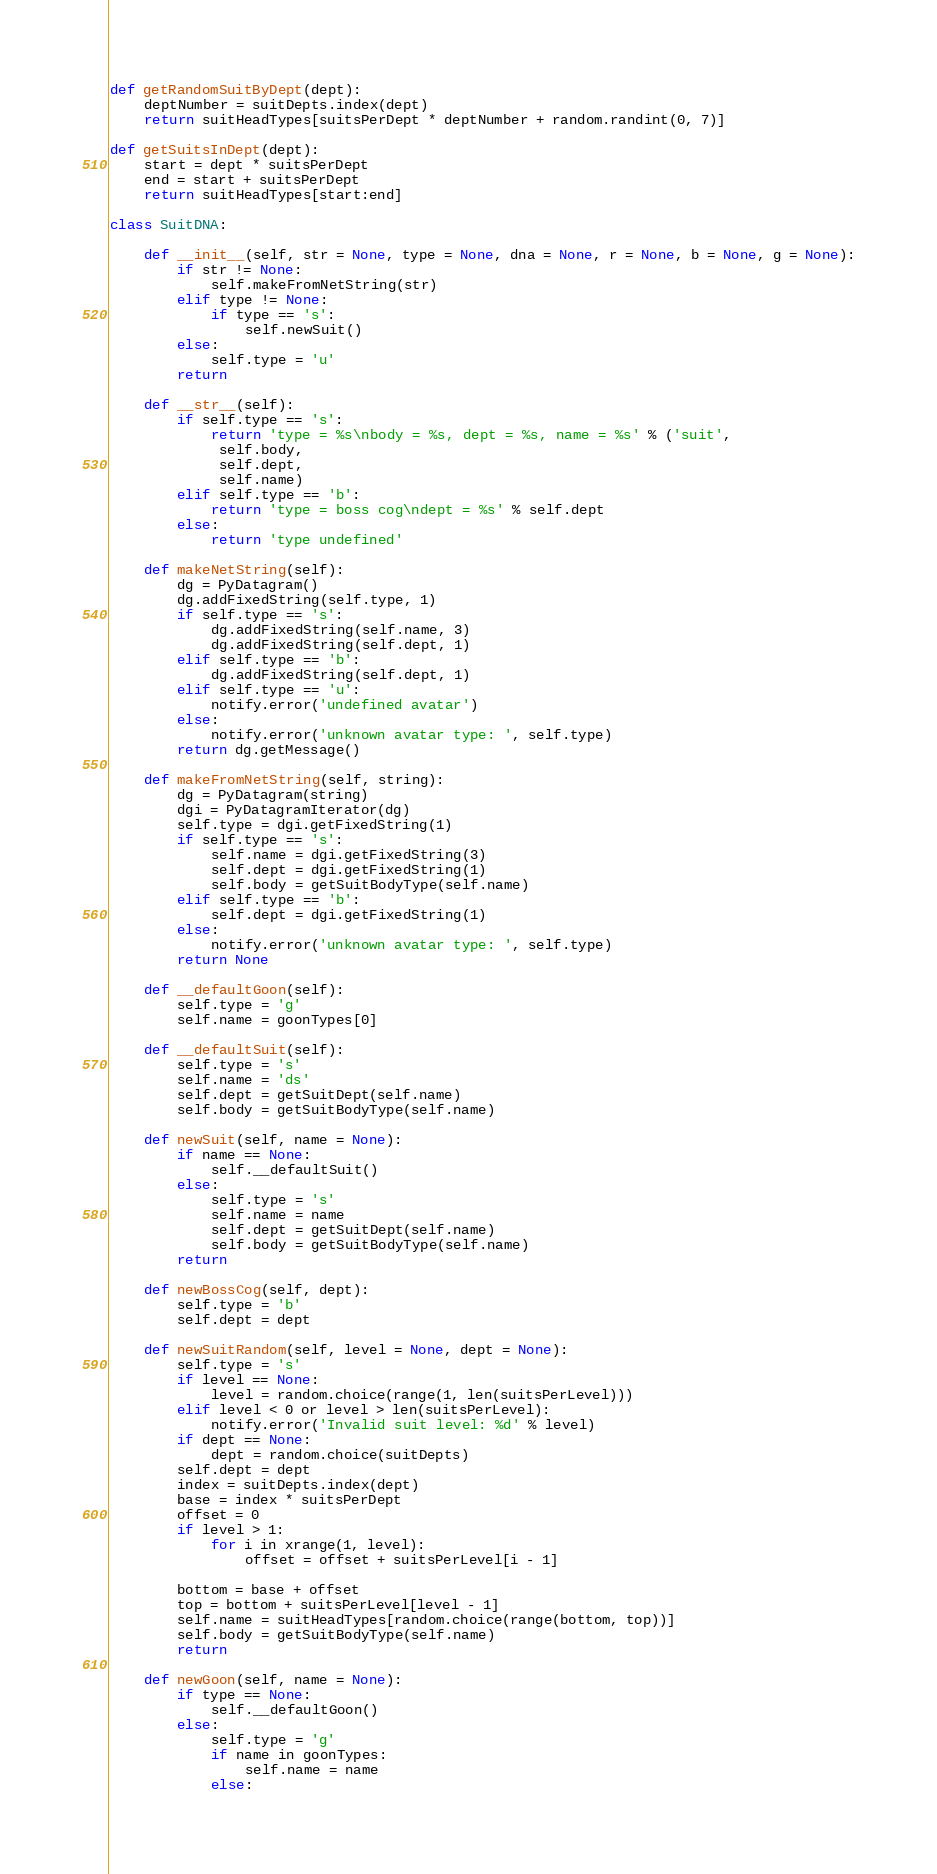Convert code to text. <code><loc_0><loc_0><loc_500><loc_500><_Python_>

def getRandomSuitByDept(dept):
    deptNumber = suitDepts.index(dept)
    return suitHeadTypes[suitsPerDept * deptNumber + random.randint(0, 7)]

def getSuitsInDept(dept):
    start = dept * suitsPerDept
    end = start + suitsPerDept
    return suitHeadTypes[start:end]

class SuitDNA:

    def __init__(self, str = None, type = None, dna = None, r = None, b = None, g = None):
        if str != None:
            self.makeFromNetString(str)
        elif type != None:
            if type == 's':
                self.newSuit()
        else:
            self.type = 'u'
        return

    def __str__(self):
        if self.type == 's':
            return 'type = %s\nbody = %s, dept = %s, name = %s' % ('suit',
             self.body,
             self.dept,
             self.name)
        elif self.type == 'b':
            return 'type = boss cog\ndept = %s' % self.dept
        else:
            return 'type undefined'

    def makeNetString(self):
        dg = PyDatagram()
        dg.addFixedString(self.type, 1)
        if self.type == 's':
            dg.addFixedString(self.name, 3)
            dg.addFixedString(self.dept, 1)
        elif self.type == 'b':
            dg.addFixedString(self.dept, 1)
        elif self.type == 'u':
            notify.error('undefined avatar')
        else:
            notify.error('unknown avatar type: ', self.type)
        return dg.getMessage()

    def makeFromNetString(self, string):
        dg = PyDatagram(string)
        dgi = PyDatagramIterator(dg)
        self.type = dgi.getFixedString(1)
        if self.type == 's':
            self.name = dgi.getFixedString(3)
            self.dept = dgi.getFixedString(1)
            self.body = getSuitBodyType(self.name)
        elif self.type == 'b':
            self.dept = dgi.getFixedString(1)
        else:
            notify.error('unknown avatar type: ', self.type)
        return None

    def __defaultGoon(self):
        self.type = 'g'
        self.name = goonTypes[0]

    def __defaultSuit(self):
        self.type = 's'
        self.name = 'ds'
        self.dept = getSuitDept(self.name)
        self.body = getSuitBodyType(self.name)

    def newSuit(self, name = None):
        if name == None:
            self.__defaultSuit()
        else:
            self.type = 's'
            self.name = name
            self.dept = getSuitDept(self.name)
            self.body = getSuitBodyType(self.name)
        return

    def newBossCog(self, dept):
        self.type = 'b'
        self.dept = dept

    def newSuitRandom(self, level = None, dept = None):
        self.type = 's'
        if level == None:
            level = random.choice(range(1, len(suitsPerLevel)))
        elif level < 0 or level > len(suitsPerLevel):
            notify.error('Invalid suit level: %d' % level)
        if dept == None:
            dept = random.choice(suitDepts)
        self.dept = dept
        index = suitDepts.index(dept)
        base = index * suitsPerDept
        offset = 0
        if level > 1:
            for i in xrange(1, level):
                offset = offset + suitsPerLevel[i - 1]

        bottom = base + offset
        top = bottom + suitsPerLevel[level - 1]
        self.name = suitHeadTypes[random.choice(range(bottom, top))]
        self.body = getSuitBodyType(self.name)
        return

    def newGoon(self, name = None):
        if type == None:
            self.__defaultGoon()
        else:
            self.type = 'g'
            if name in goonTypes:
                self.name = name
            else:</code> 